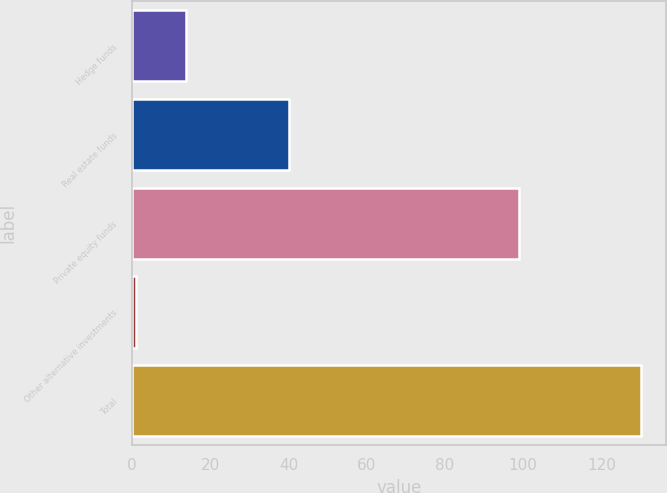Convert chart. <chart><loc_0><loc_0><loc_500><loc_500><bar_chart><fcel>Hedge funds<fcel>Real estate funds<fcel>Private equity funds<fcel>Other alternative investments<fcel>Total<nl><fcel>13.9<fcel>40<fcel>99<fcel>1<fcel>130<nl></chart> 